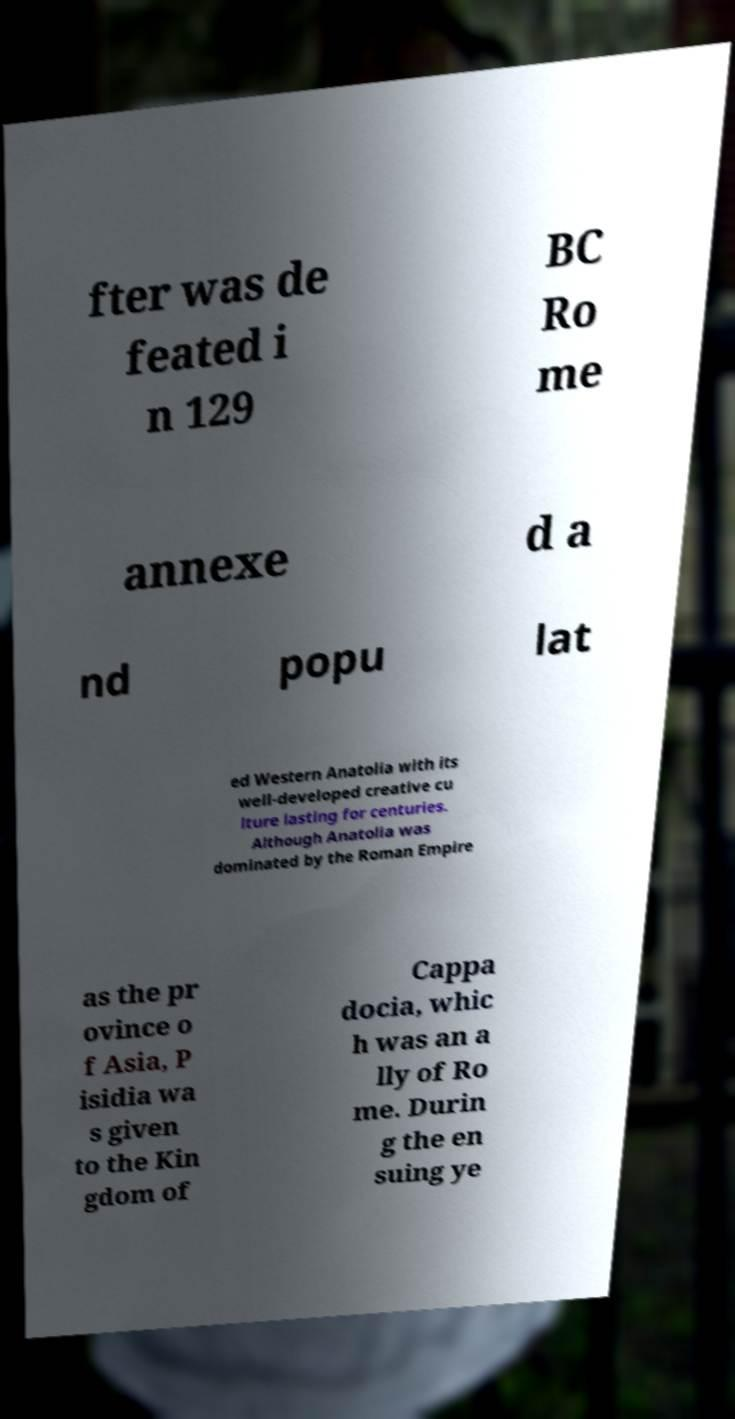Please read and relay the text visible in this image. What does it say? fter was de feated i n 129 BC Ro me annexe d a nd popu lat ed Western Anatolia with its well-developed creative cu lture lasting for centuries. Although Anatolia was dominated by the Roman Empire as the pr ovince o f Asia, P isidia wa s given to the Kin gdom of Cappa docia, whic h was an a lly of Ro me. Durin g the en suing ye 